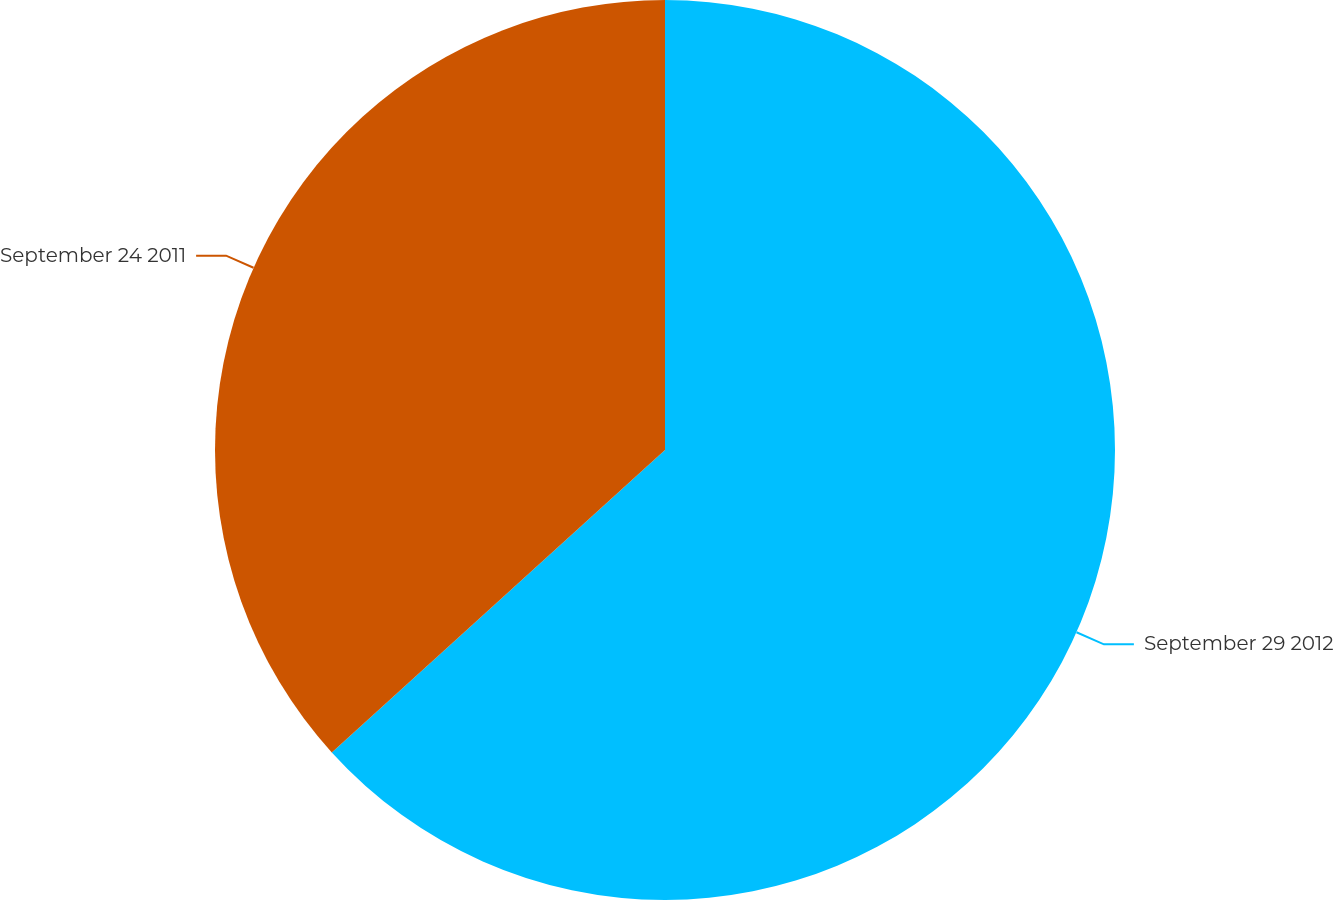<chart> <loc_0><loc_0><loc_500><loc_500><pie_chart><fcel>September 29 2012<fcel>September 24 2011<nl><fcel>63.27%<fcel>36.73%<nl></chart> 